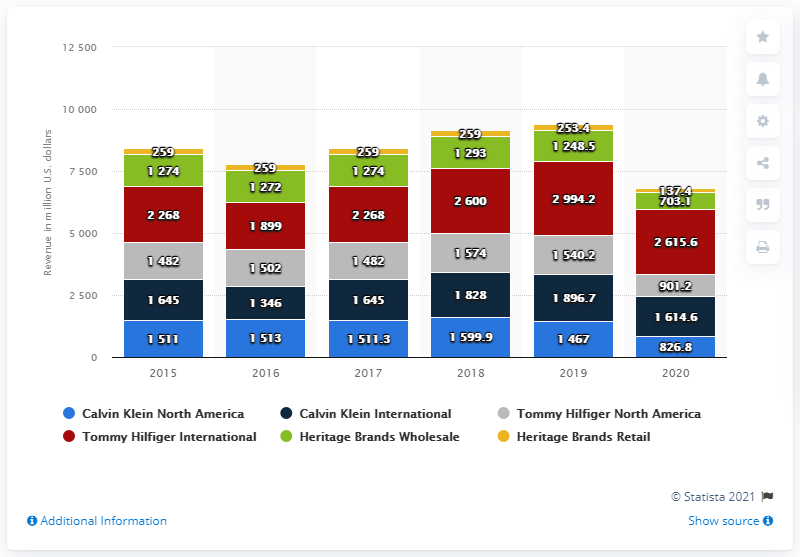Draw attention to some important aspects in this diagram. In 2020, the revenue of Calvin Klein North America was 826.8 million dollars. 